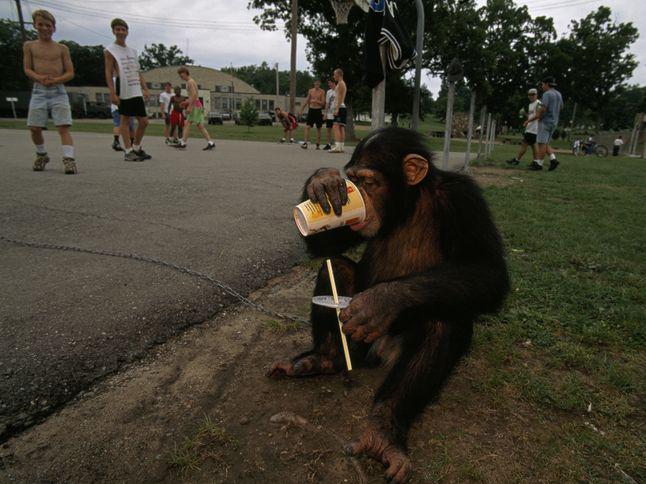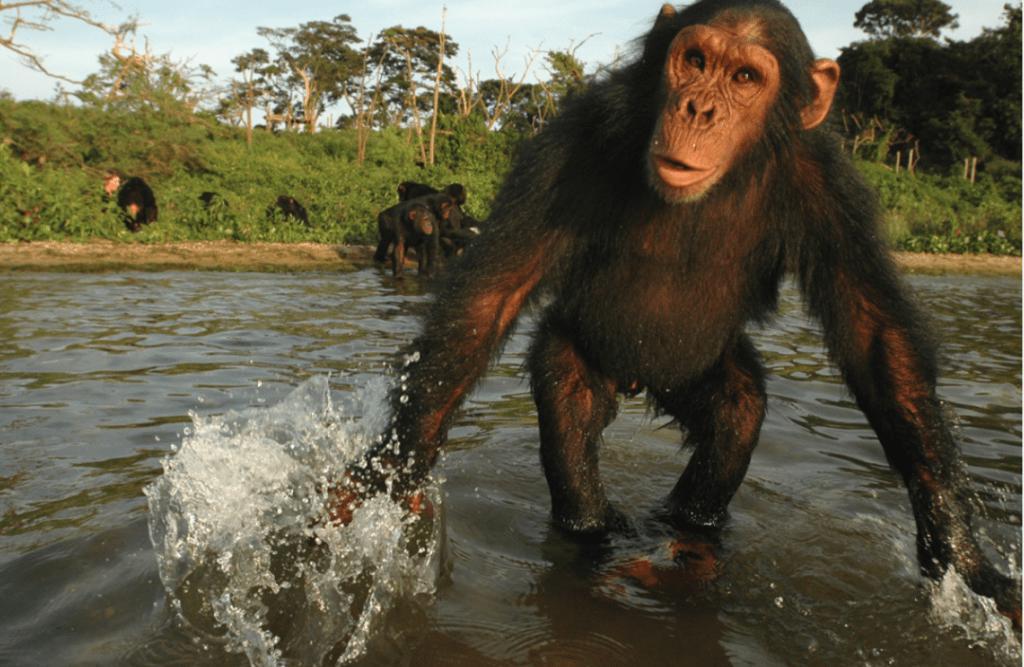The first image is the image on the left, the second image is the image on the right. Given the left and right images, does the statement "At least one of the chimps has their feet in water." hold true? Answer yes or no. Yes. The first image is the image on the left, the second image is the image on the right. Considering the images on both sides, is "The left image contains one left-facing chimp, and the right image features an ape splashing in water." valid? Answer yes or no. Yes. 